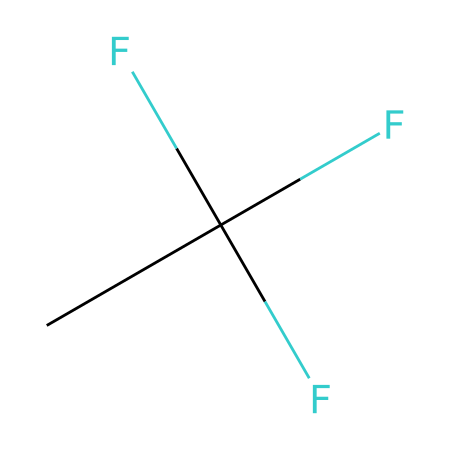What is the molecular formula of R-134a? The molecular formula is derived from the components in the SMILES representation. The structure CC(F)(F)F shows 2 carbon atoms (C) and 2 fluorine (F) atoms. Therefore, the molecular formula combines these counts into C2H2F4, reflecting the presence of hydrogen atoms as well.
Answer: C2H2F4 How many carbon atoms are present in R-134a? The SMILES notation highlights two carbon (C) atoms in the structure. The "CC" part indicates that there are two carbon atoms connected together.
Answer: 2 What functional groups are present in R-134a? In the SMILES, specifically the F(F)(F) indicates the presence of trifluoromethyl group alongside the carbon framework, and there are no other functional groups indicated.
Answer: trifluoromethyl Is R-134a a saturated or unsaturated compound? R-134a contains no double or triple bonds in its structure; it consists solely of single bonds, which classifies it as saturated.
Answer: saturated What is the significance of the fluorine atoms in the structure of R-134a? The fluorine atoms are critical in determining the chemical's refrigerant properties and stability. In refrigerants, fluorine substitution improves thermal stability and reduces flammability, making it a suitable choice for air conditioning systems.
Answer: thermal stability How many bonds are between the carbon atoms in R-134a? The two carbon atoms (C-C) present in the molecular formula are connected by a single bond, consisting solely of single bonds in this structure.
Answer: 1 What type of refrigerant is R-134a classified as? R-134a is classified as a hydrofluorocarbon (HFC), specifically designed for its use in refrigeration and air conditioning systems due to lower ozone depletion potential.
Answer: hydrofluorocarbon 